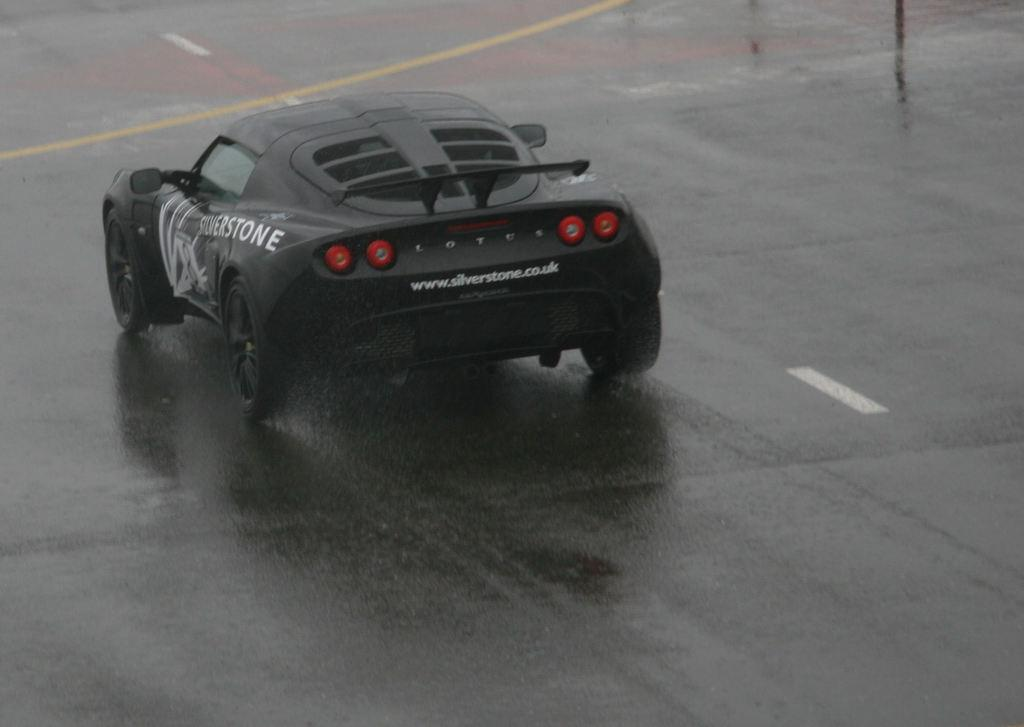What color is the car in the image? The car in the image is black. Where is the car located in the image? The car is on the road. What type of jar is placed on the car's roof in the image? There is no jar present on the car's roof in the image. 